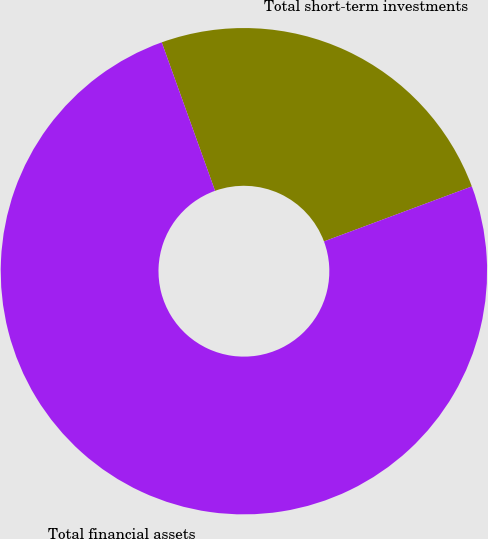Convert chart. <chart><loc_0><loc_0><loc_500><loc_500><pie_chart><fcel>Total short-term investments<fcel>Total financial assets<nl><fcel>24.82%<fcel>75.18%<nl></chart> 